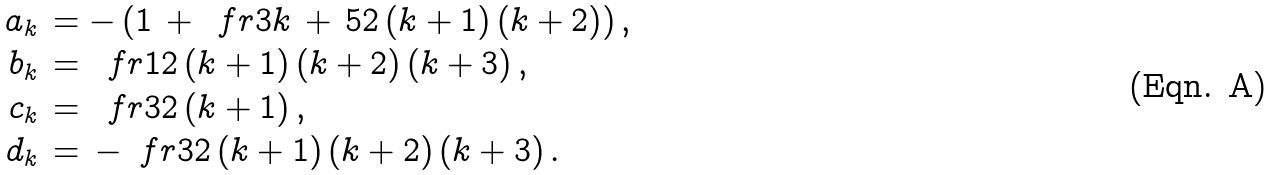<formula> <loc_0><loc_0><loc_500><loc_500>a _ { k } \, & = - \, ( 1 \, + \, \ f r { 3 k \, + \, 5 } { 2 \, ( k + 1 ) \, ( k + 2 ) } ) \, , \\ b _ { k } \, & = \, \ f r { 1 } { 2 \, ( k + 1 ) \, ( k + 2 ) \, ( k + 3 ) } \, , \\ c _ { k } \, & = \, \ f r { 3 } { 2 \, ( k + 1 ) } \, , \\ d _ { k } \, & = \, - \, \ f r { 3 } { 2 \, ( k + 1 ) \, ( k + 2 ) \, ( k + 3 ) } \, .</formula> 